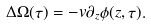<formula> <loc_0><loc_0><loc_500><loc_500>\Delta \Omega ( \tau ) = - v \partial _ { z } \phi ( z , \tau ) .</formula> 